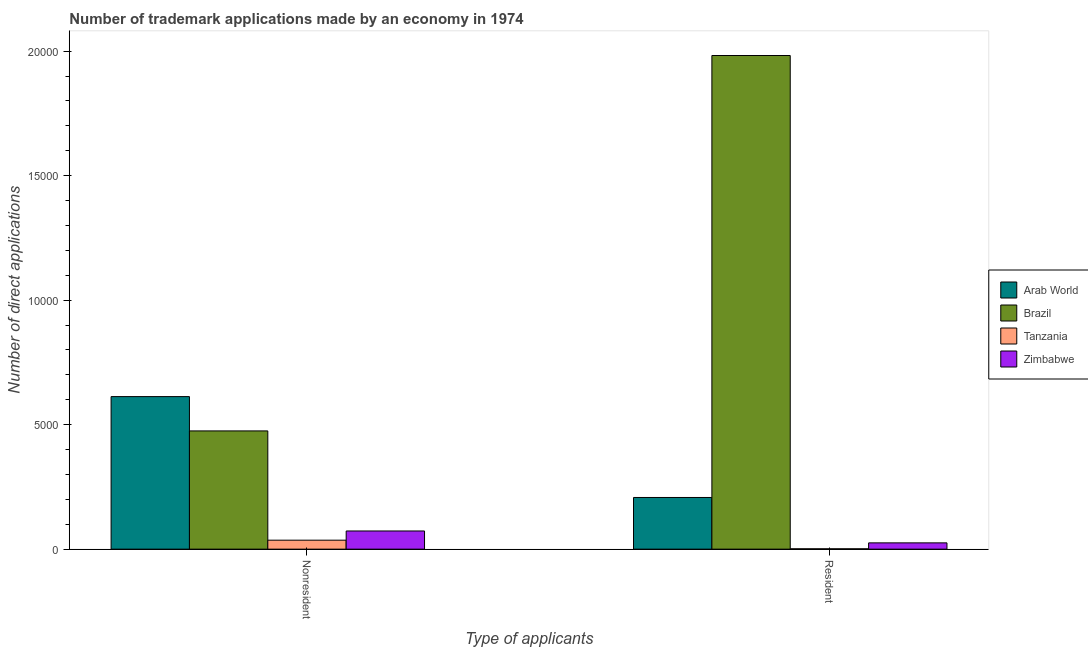How many different coloured bars are there?
Offer a very short reply. 4. Are the number of bars per tick equal to the number of legend labels?
Your answer should be compact. Yes. How many bars are there on the 1st tick from the left?
Your response must be concise. 4. How many bars are there on the 1st tick from the right?
Give a very brief answer. 4. What is the label of the 2nd group of bars from the left?
Ensure brevity in your answer.  Resident. What is the number of trademark applications made by residents in Zimbabwe?
Offer a very short reply. 252. Across all countries, what is the maximum number of trademark applications made by non residents?
Your answer should be very brief. 6126. Across all countries, what is the minimum number of trademark applications made by residents?
Your answer should be very brief. 14. In which country was the number of trademark applications made by non residents maximum?
Make the answer very short. Arab World. In which country was the number of trademark applications made by residents minimum?
Give a very brief answer. Tanzania. What is the total number of trademark applications made by residents in the graph?
Give a very brief answer. 2.22e+04. What is the difference between the number of trademark applications made by residents in Tanzania and that in Arab World?
Provide a succinct answer. -2061. What is the difference between the number of trademark applications made by non residents in Arab World and the number of trademark applications made by residents in Brazil?
Provide a succinct answer. -1.37e+04. What is the average number of trademark applications made by non residents per country?
Provide a short and direct response. 2991. What is the difference between the number of trademark applications made by residents and number of trademark applications made by non residents in Brazil?
Your answer should be compact. 1.51e+04. What is the ratio of the number of trademark applications made by non residents in Brazil to that in Tanzania?
Give a very brief answer. 13.19. In how many countries, is the number of trademark applications made by non residents greater than the average number of trademark applications made by non residents taken over all countries?
Offer a very short reply. 2. What does the 3rd bar from the left in Resident represents?
Make the answer very short. Tanzania. How many bars are there?
Provide a short and direct response. 8. How many countries are there in the graph?
Your response must be concise. 4. What is the difference between two consecutive major ticks on the Y-axis?
Keep it short and to the point. 5000. Are the values on the major ticks of Y-axis written in scientific E-notation?
Your answer should be compact. No. Does the graph contain any zero values?
Your answer should be very brief. No. What is the title of the graph?
Offer a terse response. Number of trademark applications made by an economy in 1974. What is the label or title of the X-axis?
Keep it short and to the point. Type of applicants. What is the label or title of the Y-axis?
Keep it short and to the point. Number of direct applications. What is the Number of direct applications in Arab World in Nonresident?
Provide a short and direct response. 6126. What is the Number of direct applications in Brazil in Nonresident?
Offer a very short reply. 4748. What is the Number of direct applications of Tanzania in Nonresident?
Ensure brevity in your answer.  360. What is the Number of direct applications of Zimbabwe in Nonresident?
Keep it short and to the point. 730. What is the Number of direct applications in Arab World in Resident?
Your response must be concise. 2075. What is the Number of direct applications of Brazil in Resident?
Offer a terse response. 1.98e+04. What is the Number of direct applications of Tanzania in Resident?
Provide a short and direct response. 14. What is the Number of direct applications in Zimbabwe in Resident?
Your response must be concise. 252. Across all Type of applicants, what is the maximum Number of direct applications of Arab World?
Your answer should be compact. 6126. Across all Type of applicants, what is the maximum Number of direct applications of Brazil?
Your response must be concise. 1.98e+04. Across all Type of applicants, what is the maximum Number of direct applications in Tanzania?
Your response must be concise. 360. Across all Type of applicants, what is the maximum Number of direct applications in Zimbabwe?
Make the answer very short. 730. Across all Type of applicants, what is the minimum Number of direct applications in Arab World?
Your answer should be compact. 2075. Across all Type of applicants, what is the minimum Number of direct applications of Brazil?
Keep it short and to the point. 4748. Across all Type of applicants, what is the minimum Number of direct applications of Tanzania?
Provide a succinct answer. 14. Across all Type of applicants, what is the minimum Number of direct applications in Zimbabwe?
Your answer should be very brief. 252. What is the total Number of direct applications of Arab World in the graph?
Your answer should be very brief. 8201. What is the total Number of direct applications of Brazil in the graph?
Ensure brevity in your answer.  2.46e+04. What is the total Number of direct applications of Tanzania in the graph?
Your response must be concise. 374. What is the total Number of direct applications in Zimbabwe in the graph?
Your answer should be compact. 982. What is the difference between the Number of direct applications in Arab World in Nonresident and that in Resident?
Give a very brief answer. 4051. What is the difference between the Number of direct applications in Brazil in Nonresident and that in Resident?
Make the answer very short. -1.51e+04. What is the difference between the Number of direct applications in Tanzania in Nonresident and that in Resident?
Your answer should be compact. 346. What is the difference between the Number of direct applications in Zimbabwe in Nonresident and that in Resident?
Provide a succinct answer. 478. What is the difference between the Number of direct applications in Arab World in Nonresident and the Number of direct applications in Brazil in Resident?
Provide a succinct answer. -1.37e+04. What is the difference between the Number of direct applications in Arab World in Nonresident and the Number of direct applications in Tanzania in Resident?
Keep it short and to the point. 6112. What is the difference between the Number of direct applications of Arab World in Nonresident and the Number of direct applications of Zimbabwe in Resident?
Offer a terse response. 5874. What is the difference between the Number of direct applications of Brazil in Nonresident and the Number of direct applications of Tanzania in Resident?
Your answer should be compact. 4734. What is the difference between the Number of direct applications of Brazil in Nonresident and the Number of direct applications of Zimbabwe in Resident?
Keep it short and to the point. 4496. What is the difference between the Number of direct applications of Tanzania in Nonresident and the Number of direct applications of Zimbabwe in Resident?
Offer a terse response. 108. What is the average Number of direct applications of Arab World per Type of applicants?
Offer a terse response. 4100.5. What is the average Number of direct applications in Brazil per Type of applicants?
Ensure brevity in your answer.  1.23e+04. What is the average Number of direct applications of Tanzania per Type of applicants?
Your answer should be compact. 187. What is the average Number of direct applications of Zimbabwe per Type of applicants?
Ensure brevity in your answer.  491. What is the difference between the Number of direct applications in Arab World and Number of direct applications in Brazil in Nonresident?
Your response must be concise. 1378. What is the difference between the Number of direct applications of Arab World and Number of direct applications of Tanzania in Nonresident?
Your response must be concise. 5766. What is the difference between the Number of direct applications in Arab World and Number of direct applications in Zimbabwe in Nonresident?
Keep it short and to the point. 5396. What is the difference between the Number of direct applications of Brazil and Number of direct applications of Tanzania in Nonresident?
Your answer should be compact. 4388. What is the difference between the Number of direct applications of Brazil and Number of direct applications of Zimbabwe in Nonresident?
Ensure brevity in your answer.  4018. What is the difference between the Number of direct applications in Tanzania and Number of direct applications in Zimbabwe in Nonresident?
Offer a terse response. -370. What is the difference between the Number of direct applications of Arab World and Number of direct applications of Brazil in Resident?
Offer a terse response. -1.77e+04. What is the difference between the Number of direct applications of Arab World and Number of direct applications of Tanzania in Resident?
Ensure brevity in your answer.  2061. What is the difference between the Number of direct applications in Arab World and Number of direct applications in Zimbabwe in Resident?
Your answer should be compact. 1823. What is the difference between the Number of direct applications of Brazil and Number of direct applications of Tanzania in Resident?
Offer a very short reply. 1.98e+04. What is the difference between the Number of direct applications of Brazil and Number of direct applications of Zimbabwe in Resident?
Provide a short and direct response. 1.96e+04. What is the difference between the Number of direct applications in Tanzania and Number of direct applications in Zimbabwe in Resident?
Offer a terse response. -238. What is the ratio of the Number of direct applications of Arab World in Nonresident to that in Resident?
Offer a very short reply. 2.95. What is the ratio of the Number of direct applications of Brazil in Nonresident to that in Resident?
Provide a short and direct response. 0.24. What is the ratio of the Number of direct applications in Tanzania in Nonresident to that in Resident?
Offer a very short reply. 25.71. What is the ratio of the Number of direct applications in Zimbabwe in Nonresident to that in Resident?
Offer a terse response. 2.9. What is the difference between the highest and the second highest Number of direct applications of Arab World?
Offer a terse response. 4051. What is the difference between the highest and the second highest Number of direct applications in Brazil?
Keep it short and to the point. 1.51e+04. What is the difference between the highest and the second highest Number of direct applications in Tanzania?
Your response must be concise. 346. What is the difference between the highest and the second highest Number of direct applications of Zimbabwe?
Provide a short and direct response. 478. What is the difference between the highest and the lowest Number of direct applications of Arab World?
Provide a succinct answer. 4051. What is the difference between the highest and the lowest Number of direct applications of Brazil?
Your response must be concise. 1.51e+04. What is the difference between the highest and the lowest Number of direct applications in Tanzania?
Offer a terse response. 346. What is the difference between the highest and the lowest Number of direct applications of Zimbabwe?
Your answer should be compact. 478. 